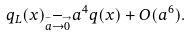Convert formula to latex. <formula><loc_0><loc_0><loc_500><loc_500>q _ { L } ( x ) _ { \stackrel { - \, \longrightarrow } { a \rightarrow 0 } } a ^ { 4 } q ( x ) + O ( a ^ { 6 } ) .</formula> 